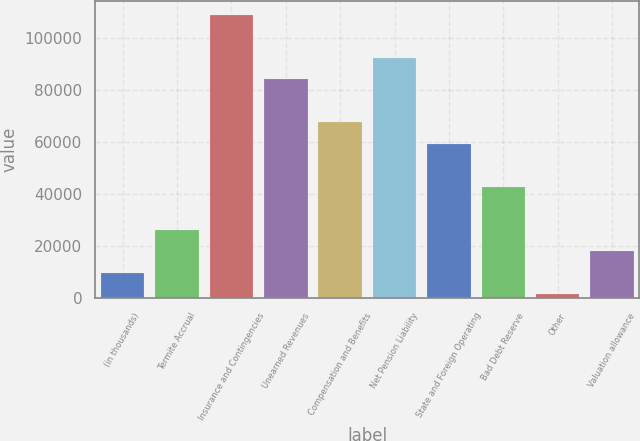<chart> <loc_0><loc_0><loc_500><loc_500><bar_chart><fcel>(in thousands)<fcel>Termite Accrual<fcel>Insurance and Contingencies<fcel>Unearned Revenues<fcel>Compensation and Benefits<fcel>Net Pension Liability<fcel>State and Foreign Operating<fcel>Bad Debt Reserve<fcel>Other<fcel>Valuation allowance<nl><fcel>9651.4<fcel>26186.2<fcel>108860<fcel>84058<fcel>67523.2<fcel>92325.4<fcel>59255.8<fcel>42721<fcel>1384<fcel>17918.8<nl></chart> 